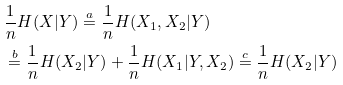<formula> <loc_0><loc_0><loc_500><loc_500>& \frac { 1 } { n } H ( { X } | { Y } ) \overset { a } { = } \frac { 1 } { n } H ( { X _ { 1 } } , { X _ { 2 } } | { Y } ) \\ & \overset { b } { = } \frac { 1 } { n } H ( { X _ { 2 } } | { Y } ) + \frac { 1 } { n } H ( { X _ { 1 } } | { Y } , { X _ { 2 } } ) \overset { c } { = } \frac { 1 } { n } H ( { X _ { 2 } } | { Y } )</formula> 